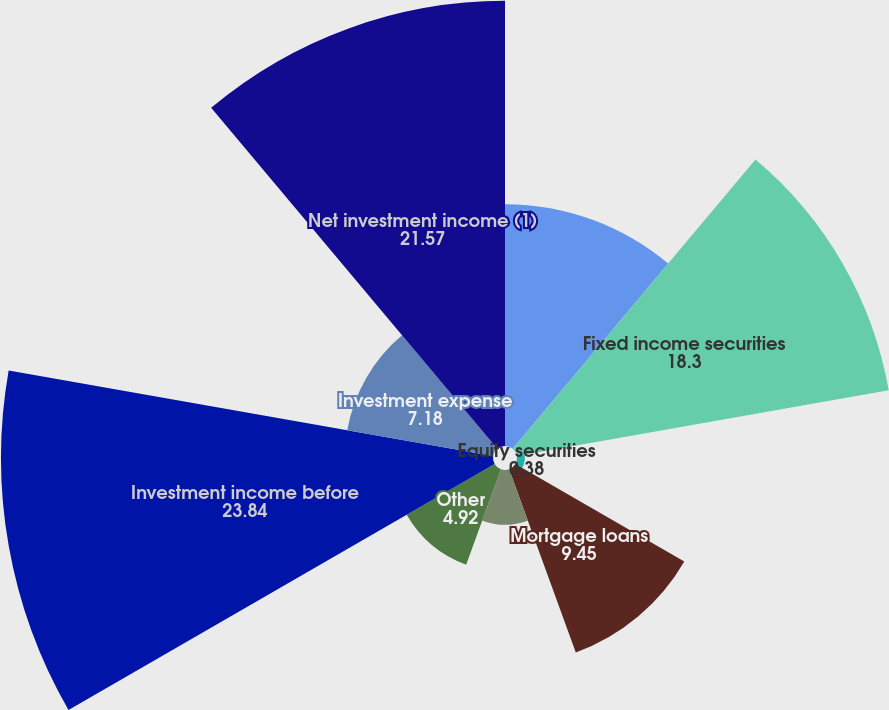<chart> <loc_0><loc_0><loc_500><loc_500><pie_chart><fcel>( in millions)<fcel>Fixed income securities<fcel>Equity securities<fcel>Mortgage loans<fcel>Limited partnership interests<fcel>Other<fcel>Investment income before<fcel>Investment expense<fcel>Net investment income (1)<nl><fcel>11.72%<fcel>18.3%<fcel>0.38%<fcel>9.45%<fcel>2.65%<fcel>4.92%<fcel>23.84%<fcel>7.18%<fcel>21.57%<nl></chart> 